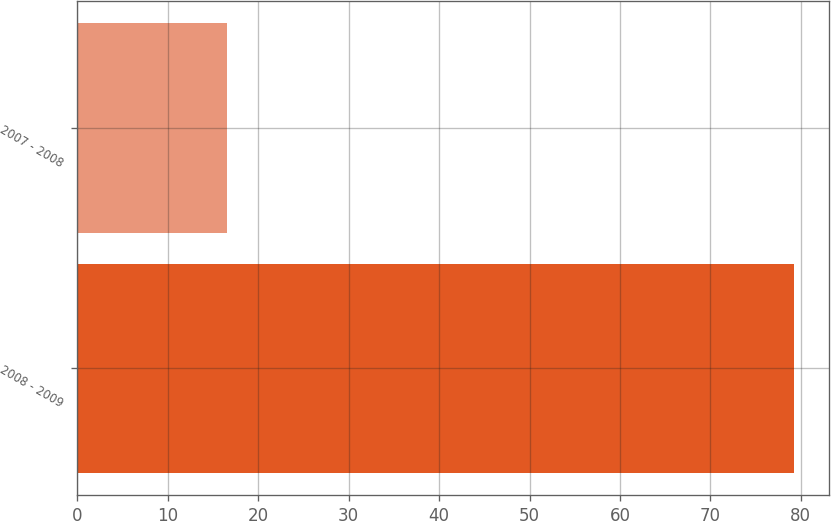Convert chart to OTSL. <chart><loc_0><loc_0><loc_500><loc_500><bar_chart><fcel>2008 - 2009<fcel>2007 - 2008<nl><fcel>79.2<fcel>16.5<nl></chart> 